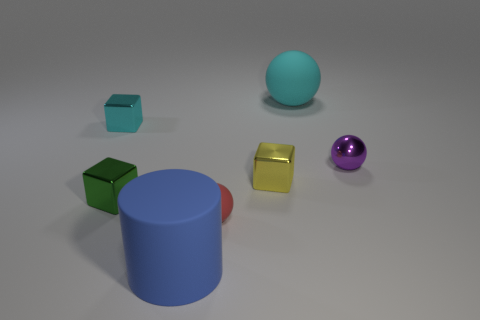Subtract all big rubber balls. How many balls are left? 2 Add 2 small purple metallic things. How many objects exist? 9 Subtract all yellow blocks. How many blocks are left? 2 Subtract 1 cylinders. How many cylinders are left? 0 Subtract 0 red cylinders. How many objects are left? 7 Subtract all cylinders. How many objects are left? 6 Subtract all brown cubes. Subtract all green spheres. How many cubes are left? 3 Subtract all green cylinders. How many red spheres are left? 1 Subtract all tiny red matte spheres. Subtract all red balls. How many objects are left? 5 Add 6 cyan matte objects. How many cyan matte objects are left? 7 